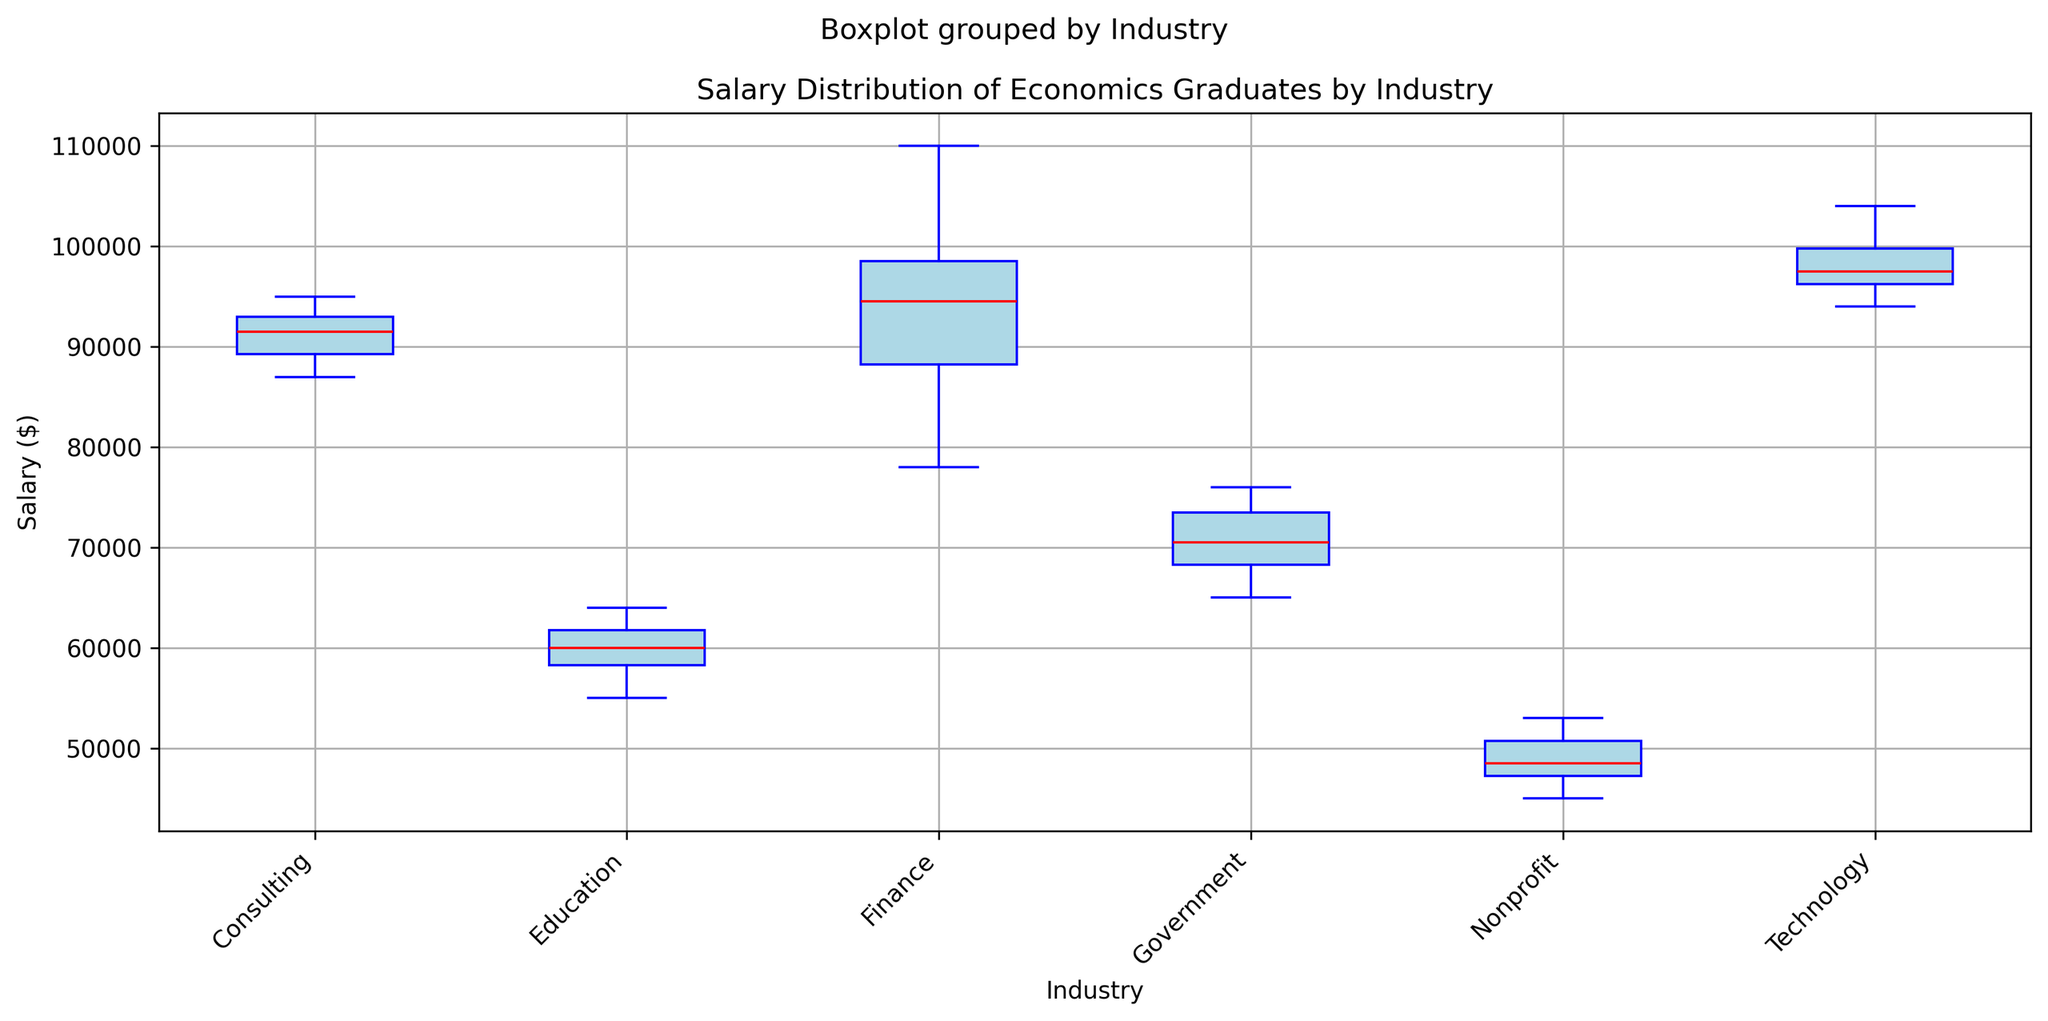What's the median salary in the Technology industry? The median salary is the middle value of the ordered data points. In the Technology industry, from the box plot, the median (red line) appears to be around $97,000.
Answer: $97,000 Which industry has the highest median salary? The industry with the highest median salary is identified by comparing the median values (red lines) of all industries. The Finance industry's red line appears to be the highest.
Answer: Finance What is the interquartile range (IQR) for the Finance industry's salary distribution? The IQR is the difference between the third quartile (Q3) and the first quartile (Q1). From the box plot, Q3 (top of the box) for Finance is approximately $99,000 and Q1 (bottom of the box) is around $88,000. Therefore, IQR = Q3 - Q1 = $99,000 - $88,000 = $11,000.
Answer: $11,000 Which industry has the widest range of salaries? The range is determined by the difference between the minimum and maximum values (whiskers). The Technology industry shows the widest range, with the lower whisker around $94,000 and the upper whisker around $104,000, giving a range of $10,000.
Answer: Technology How does the median salary in Consulting compare to that in Education? By examining the red lines in the box plots, the median salary for Consulting is around $91,000, while for Education it is around $60,000. The Consulting median is higher.
Answer: Consulting has a higher median Are there any outliers in the Finance industry's salary distribution? Outliers are represented by individual points outside the whiskers. In Finance, there are no dots outside the whiskers, indicating there are no outliers.
Answer: No Which industry seems to have the lowest variability in salary? Variability can be inferred from the height of the boxes and length of the whiskers. The shortest box and whiskers combination is observed in Education, suggesting it has the lowest variability.
Answer: Education Does the Nonprofit industry have any salaries above $55,000? The upper whisker in the Nonprofit industry's box plot reaches just above $50,000, indicating no salaries exceed $55,000.
Answer: No What's the average salary of the highest-paying jobs in the Finance industry? Consider the top 25% of the data. The top 25% means the salaries above Q3. For Finance, Q3 is approximately $99,000. The salaries in this range are $99,000, $102,000, $110,000, and $97,000. The average of these is (99,000 + 102,000 + 110,000 + 97,000) / 4 = $102,000.
Answer: $102,000 Which industry has the smallest interquartile range (IQR) and what is it? The industry with the smallest IQR has the shortest box. Comparing box lengths, Education's box appears shortest, and its IQR is calculated as Q3 ($63,000) - Q1 ($58,000) = $5,000.
Answer: Education, $5,000 